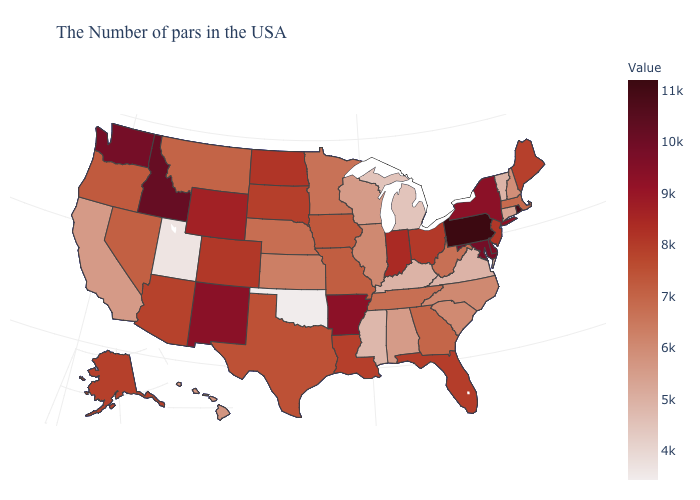Does Oklahoma have the lowest value in the USA?
Give a very brief answer. Yes. Does North Carolina have the highest value in the South?
Write a very short answer. No. Which states have the lowest value in the USA?
Write a very short answer. Oklahoma. Does Indiana have a higher value than New Mexico?
Concise answer only. No. 